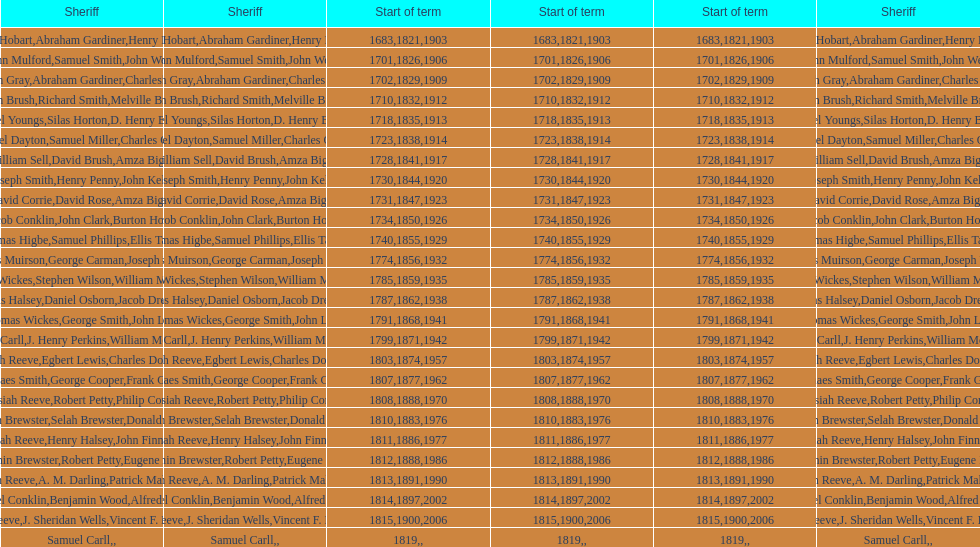How sheriffs has suffolk county had in total? 76. 